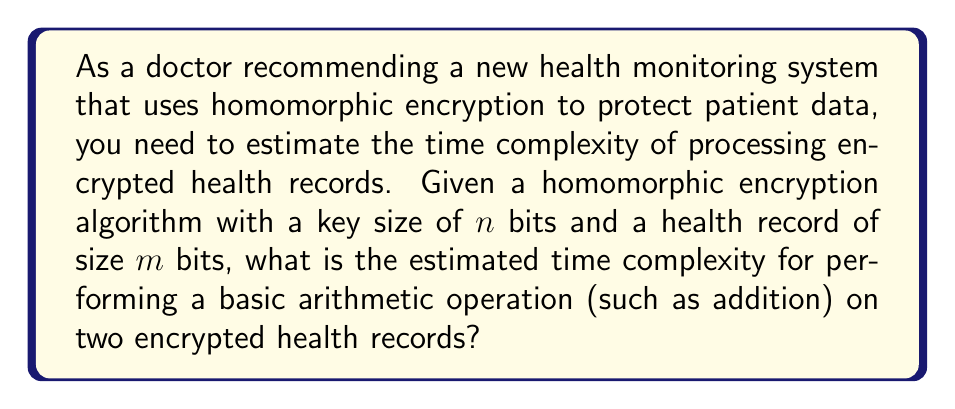What is the answer to this math problem? To estimate the time complexity of performing a basic arithmetic operation on two encrypted health records using homomorphic encryption, we need to consider the following steps:

1. Understand the basics of homomorphic encryption:
   Homomorphic encryption allows computations to be performed on encrypted data without decrypting it. The most common fully homomorphic encryption schemes are based on lattice-based cryptography.

2. Consider the key size and record size:
   - Key size: $n$ bits
   - Health record size: $m$ bits

3. Analyze the complexity of basic operations in lattice-based cryptography:
   The fundamental operation in lattice-based cryptography is typically matrix multiplication or polynomial multiplication.

4. Estimate the complexity of encrypting a health record:
   Encryption typically involves multiplying the plaintext by a matrix or polynomial of size proportional to the key size. This operation has a time complexity of $O(n^2m)$.

5. Estimate the complexity of performing an arithmetic operation on encrypted data:
   For homomorphic addition or multiplication, we need to perform operations on the encrypted data, which are typically matrices or polynomials of size proportional to both $n$ and $m$. The time complexity for this operation is generally $O(n^2m^2)$.

6. Consider optimizations:
   Some optimizations, such as using the Fast Fourier Transform (FFT) for polynomial multiplication, can reduce the complexity to $O(nm \log(nm))$. However, for a conservative estimate, we'll use the higher complexity.

7. Conclude:
   The estimated time complexity for performing a basic arithmetic operation on two encrypted health records using homomorphic encryption is $O(n^2m^2)$, where $n$ is the key size and $m$ is the record size in bits.
Answer: $O(n^2m^2)$ 